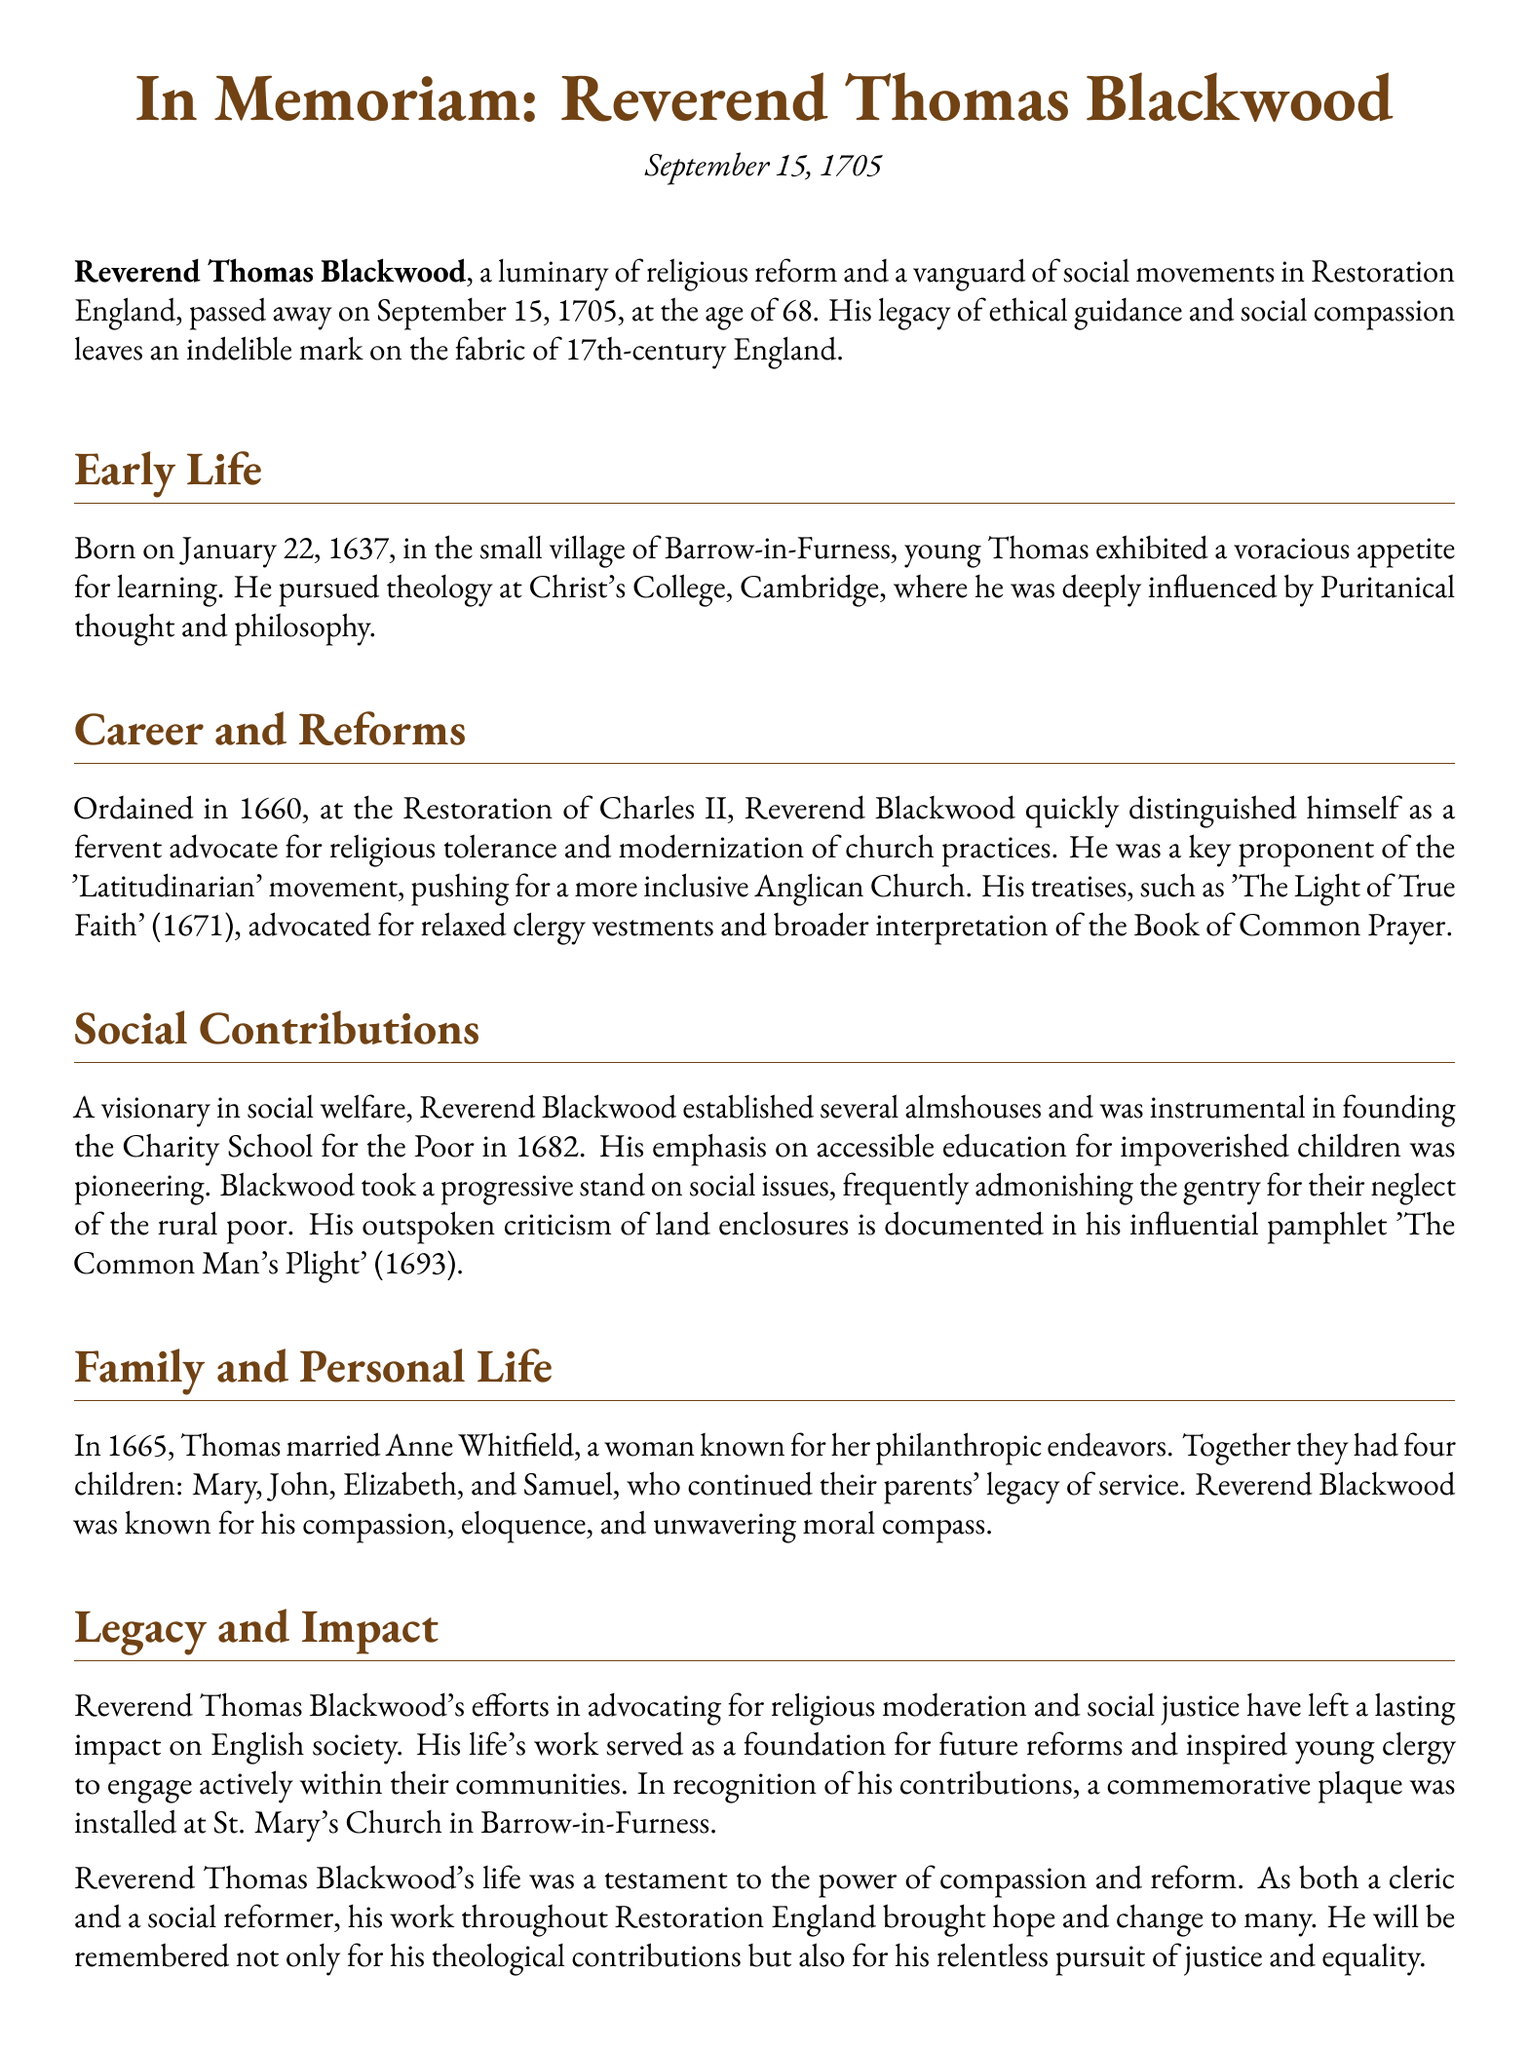What date did Reverend Thomas Blackwood pass away? The obituary states that Reverend Thomas Blackwood passed away on September 15, 1705.
Answer: September 15, 1705 What was the title of Reverend Blackwood's treatise published in 1671? The title of the treatise published in 1671 is 'The Light of True Faith'.
Answer: The Light of True Faith How many children did Reverend Blackwood have? The document mentions that Reverend Blackwood had four children: Mary, John, Elizabeth, and Samuel.
Answer: Four What was one social contribution Reverend Blackwood made in 1682? The document states that Reverend Blackwood was instrumental in founding the Charity School for the Poor in 1682.
Answer: Charity School for the Poor Which movement was Reverend Blackwood a key proponent of? The obituary indicates that Reverend Blackwood was a key proponent of the 'Latitudinarian' movement.
Answer: Latitudinarian How old was Reverend Blackwood at the time of his death? The document reveals that Reverend Blackwood passed away at the age of 68.
Answer: 68 What significant issue did Reverend Blackwood criticize in his pamphlet 'The Common Man's Plight'? The pamphlet 'The Common Man's Plight' addressed the issue of land enclosures.
Answer: Land enclosures What was Reverend Blackwood's stance on clergy vestments? He advocated for relaxed clergy vestments according to his writings.
Answer: Relaxed clergy vestments 